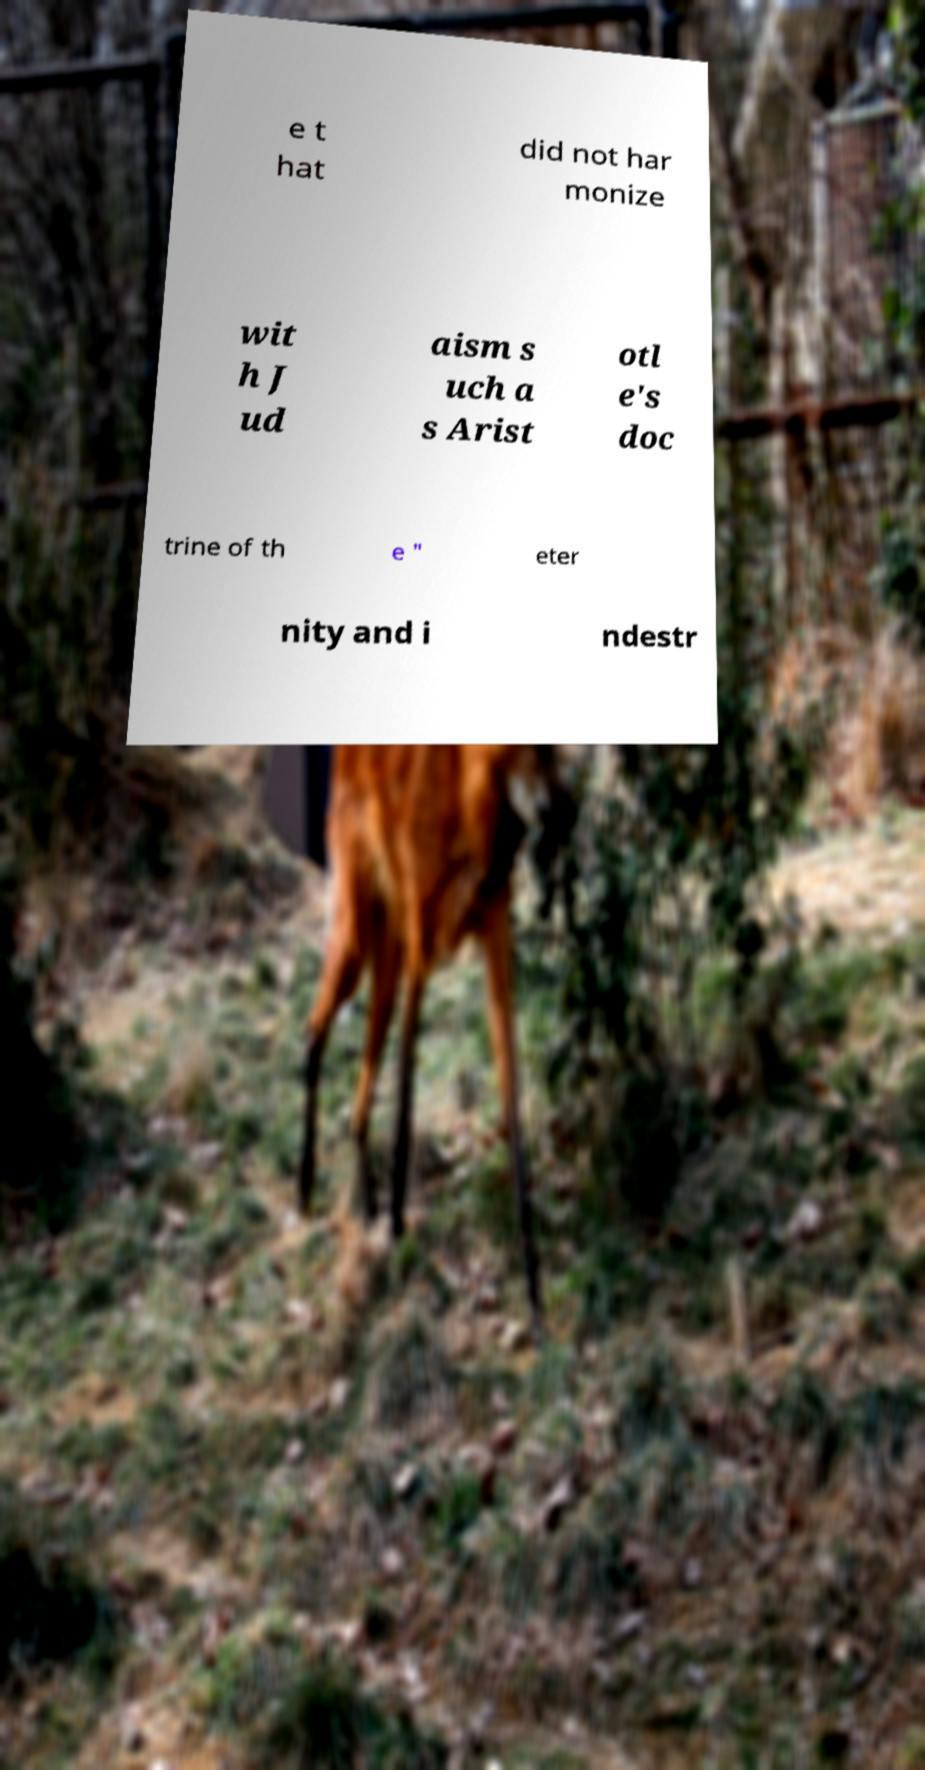Please read and relay the text visible in this image. What does it say? e t hat did not har monize wit h J ud aism s uch a s Arist otl e's doc trine of th e " eter nity and i ndestr 